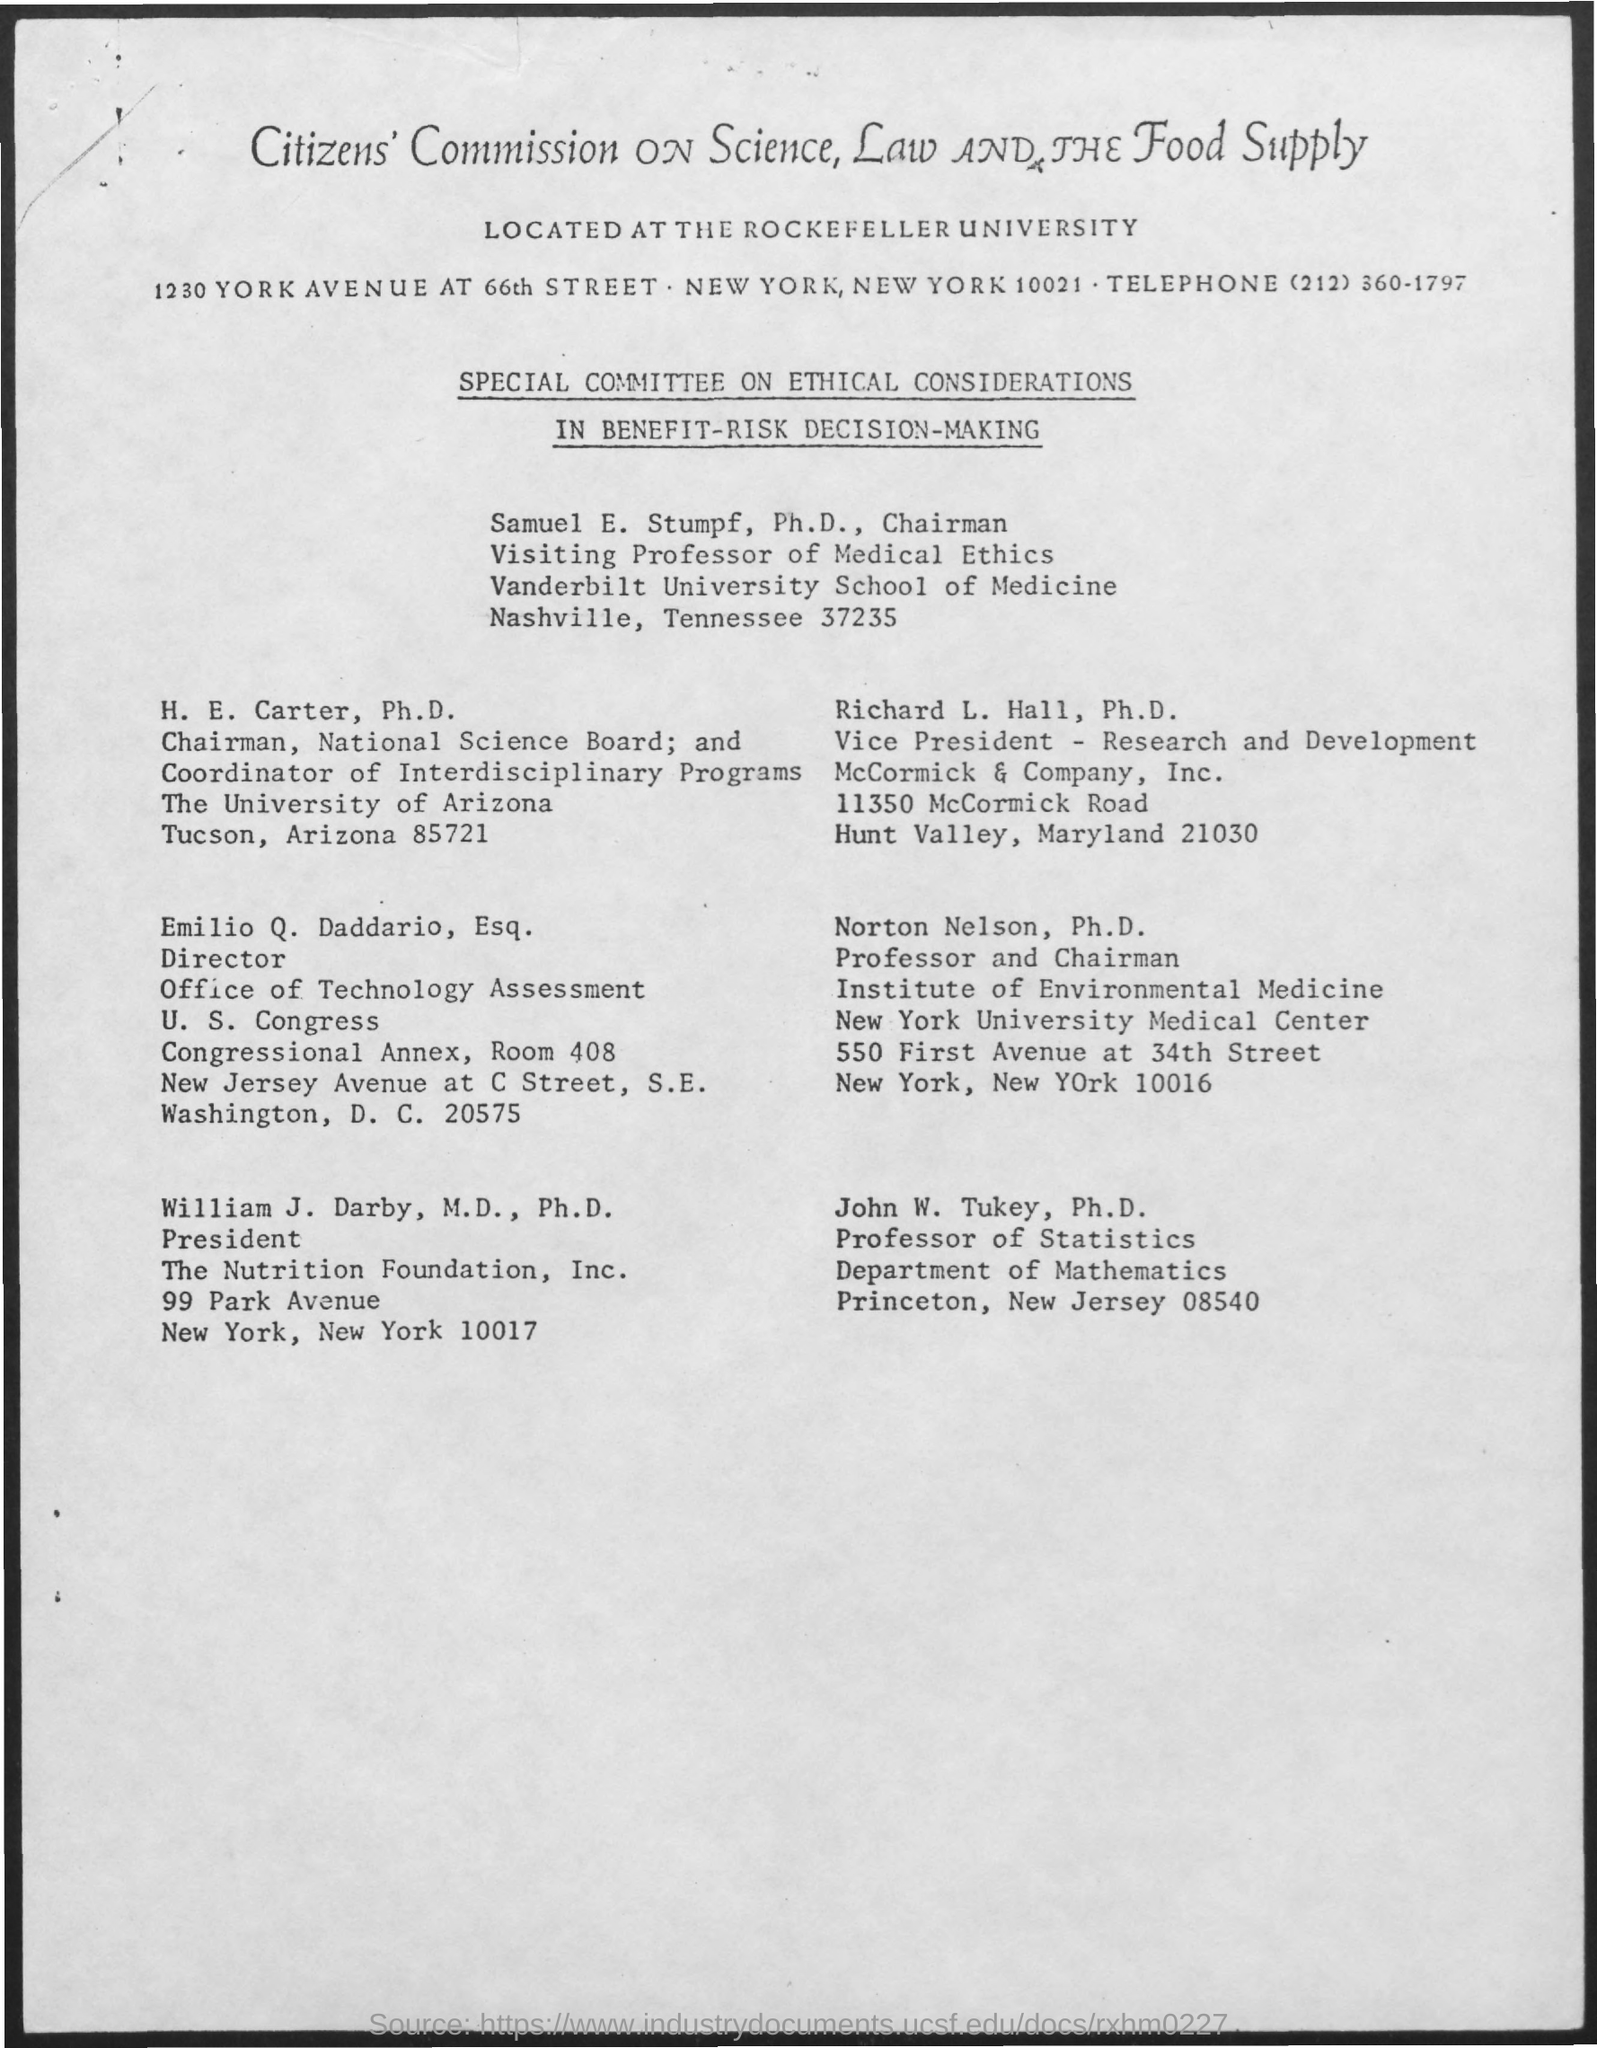What is the designation of john w. turkey ?
Provide a short and direct response. Professor of statistics. To which department john w. turkey belongs to ?
Make the answer very short. Department of Mathematics. What is the designation of norton nelson mentioned ?
Ensure brevity in your answer.  Professor and Chairman. What is the designation of william j. darby ?
Give a very brief answer. President. What is the telephone no. mentioned in the given page ?
Offer a very short reply. (212) 360-1797. 